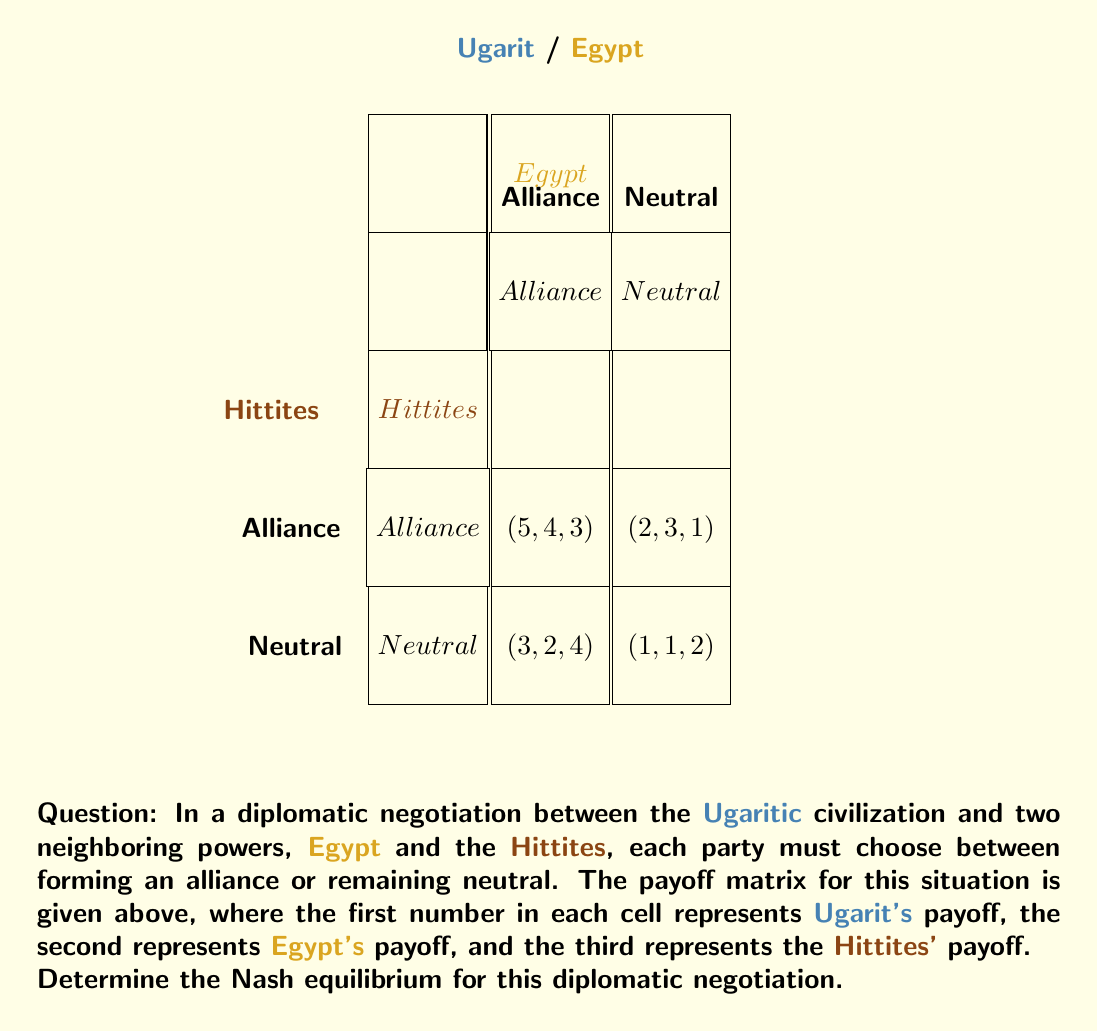Could you help me with this problem? To find the Nash equilibrium, we need to analyze each player's best response to the other players' strategies:

1. Ugarit's perspective:
   - If Egypt and Hittites both choose Alliance: $5 > 2$, so Ugarit chooses Alliance
   - If Egypt chooses Alliance and Hittites choose Neutral: $5 > 3$, so Ugarit chooses Alliance
   - If Egypt chooses Neutral and Hittites choose Alliance: $2 > 1$, so Ugarit chooses Alliance
   - If Egypt and Hittites both choose Neutral: $2 > 1$, so Ugarit chooses Alliance

2. Egypt's perspective:
   - If Ugarit and Hittites both choose Alliance: $4 > 2$, so Egypt chooses Alliance
   - If Ugarit chooses Alliance and Hittites choose Neutral: $4 > 3$, so Egypt chooses Alliance
   - If Ugarit chooses Neutral and Hittites choose Alliance: $3 > 1$, so Egypt chooses Alliance
   - If Ugarit and Hittites both choose Neutral: $3 > 1$, so Egypt chooses Alliance

3. Hittites' perspective:
   - If Ugarit and Egypt both choose Alliance: $3 > 1$, so Hittites choose Alliance
   - If Ugarit chooses Alliance and Egypt chooses Neutral: $4 > 2$, so Hittites choose Alliance
   - If Ugarit chooses Neutral and Egypt chooses Alliance: $3 > 1$, so Hittites choose Alliance
   - If Ugarit and Egypt both choose Neutral: $4 > 2$, so Hittites choose Alliance

From this analysis, we can see that regardless of what the other players do, each civilization's best strategy is to choose Alliance. Therefore, the Nash equilibrium is (Alliance, Alliance, Alliance) with payoffs (5, 4, 3) for Ugarit, Egypt, and the Hittites, respectively.
Answer: (Alliance, Alliance, Alliance) 